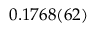Convert formula to latex. <formula><loc_0><loc_0><loc_500><loc_500>0 . 1 7 6 8 ( 6 2 )</formula> 